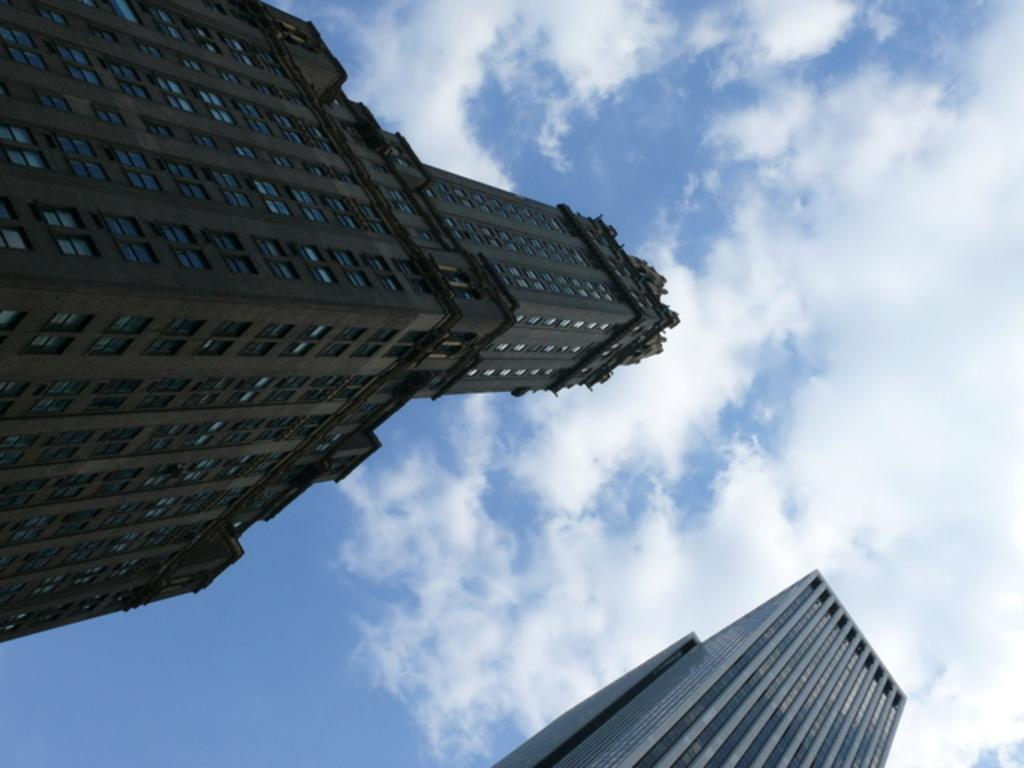What type of buildings can be seen in the image? There are skyscrapers in the image. In which direction do the skyscrapers twist in the image? The skyscrapers do not twist in the image; they are depicted as straight structures. 